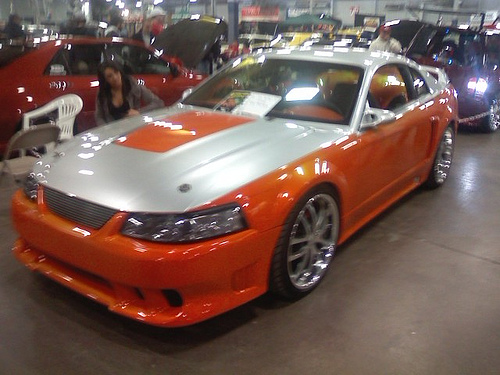<image>
Can you confirm if the car is behind the women? No. The car is not behind the women. From this viewpoint, the car appears to be positioned elsewhere in the scene. 